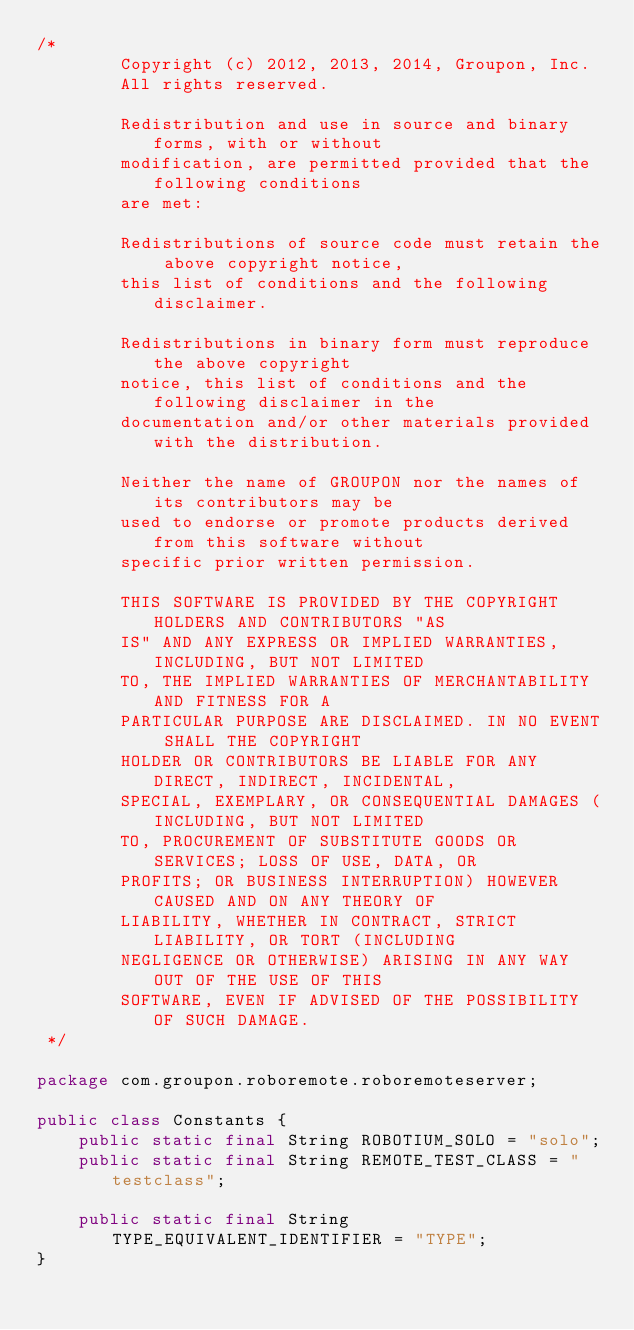Convert code to text. <code><loc_0><loc_0><loc_500><loc_500><_Java_>/*
        Copyright (c) 2012, 2013, 2014, Groupon, Inc.
        All rights reserved.

        Redistribution and use in source and binary forms, with or without
        modification, are permitted provided that the following conditions
        are met:

        Redistributions of source code must retain the above copyright notice,
        this list of conditions and the following disclaimer.

        Redistributions in binary form must reproduce the above copyright
        notice, this list of conditions and the following disclaimer in the
        documentation and/or other materials provided with the distribution.

        Neither the name of GROUPON nor the names of its contributors may be
        used to endorse or promote products derived from this software without
        specific prior written permission.

        THIS SOFTWARE IS PROVIDED BY THE COPYRIGHT HOLDERS AND CONTRIBUTORS "AS
        IS" AND ANY EXPRESS OR IMPLIED WARRANTIES, INCLUDING, BUT NOT LIMITED
        TO, THE IMPLIED WARRANTIES OF MERCHANTABILITY AND FITNESS FOR A
        PARTICULAR PURPOSE ARE DISCLAIMED. IN NO EVENT SHALL THE COPYRIGHT
        HOLDER OR CONTRIBUTORS BE LIABLE FOR ANY DIRECT, INDIRECT, INCIDENTAL,
        SPECIAL, EXEMPLARY, OR CONSEQUENTIAL DAMAGES (INCLUDING, BUT NOT LIMITED
        TO, PROCUREMENT OF SUBSTITUTE GOODS OR SERVICES; LOSS OF USE, DATA, OR
        PROFITS; OR BUSINESS INTERRUPTION) HOWEVER CAUSED AND ON ANY THEORY OF
        LIABILITY, WHETHER IN CONTRACT, STRICT LIABILITY, OR TORT (INCLUDING
        NEGLIGENCE OR OTHERWISE) ARISING IN ANY WAY OUT OF THE USE OF THIS
        SOFTWARE, EVEN IF ADVISED OF THE POSSIBILITY OF SUCH DAMAGE.
 */

package com.groupon.roboremote.roboremoteserver;

public class Constants {
    public static final String ROBOTIUM_SOLO = "solo";
    public static final String REMOTE_TEST_CLASS = "testclass";

    public static final String TYPE_EQUIVALENT_IDENTIFIER = "TYPE";
}
</code> 